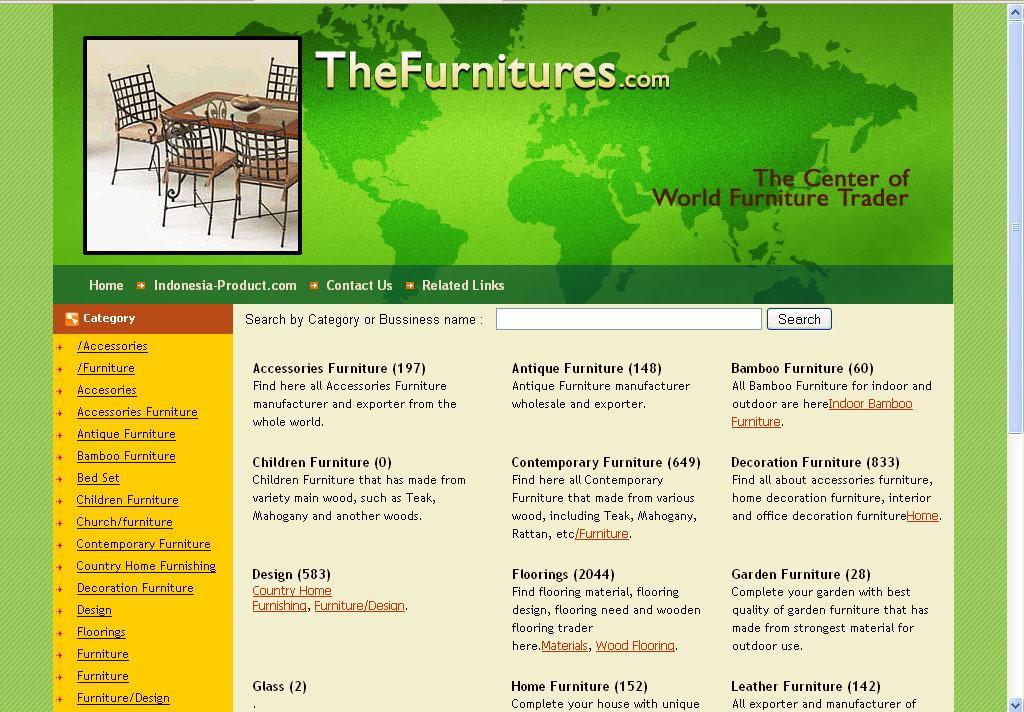How would you summarize this image in a sentence or two? Here in this picture we can see a web page, in which we can see a picture of a table and chairs and we can also see some text present. 